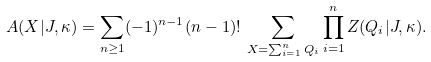Convert formula to latex. <formula><loc_0><loc_0><loc_500><loc_500>A ( X | J , \kappa ) = \sum _ { n \geq 1 } ( - 1 ) ^ { n - 1 } ( n - 1 ) ! \, \sum _ { X = \sum _ { i = 1 } ^ { n } Q _ { i } } \prod _ { i = 1 } ^ { n } Z ( Q _ { i } | J , \kappa ) .</formula> 